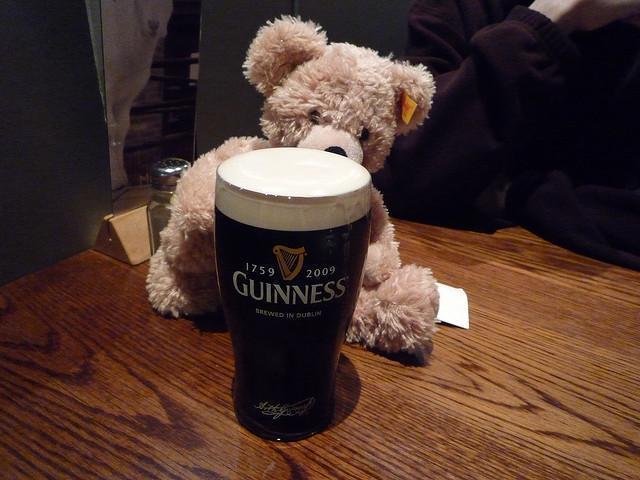What plant adds bitterness to this beverage?
Select the accurate answer and provide explanation: 'Answer: answer
Rationale: rationale.'
Options: Hops, corn, mugwort, sugar. Answer: hops.
Rationale: Traditionally all beers have hops in them. 